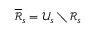Convert formula to latex. <formula><loc_0><loc_0><loc_500><loc_500>\overline { { \mathcal { R } } } _ { s } = \mathcal { U } _ { s } \ \mathcal { R } _ { s }</formula> 